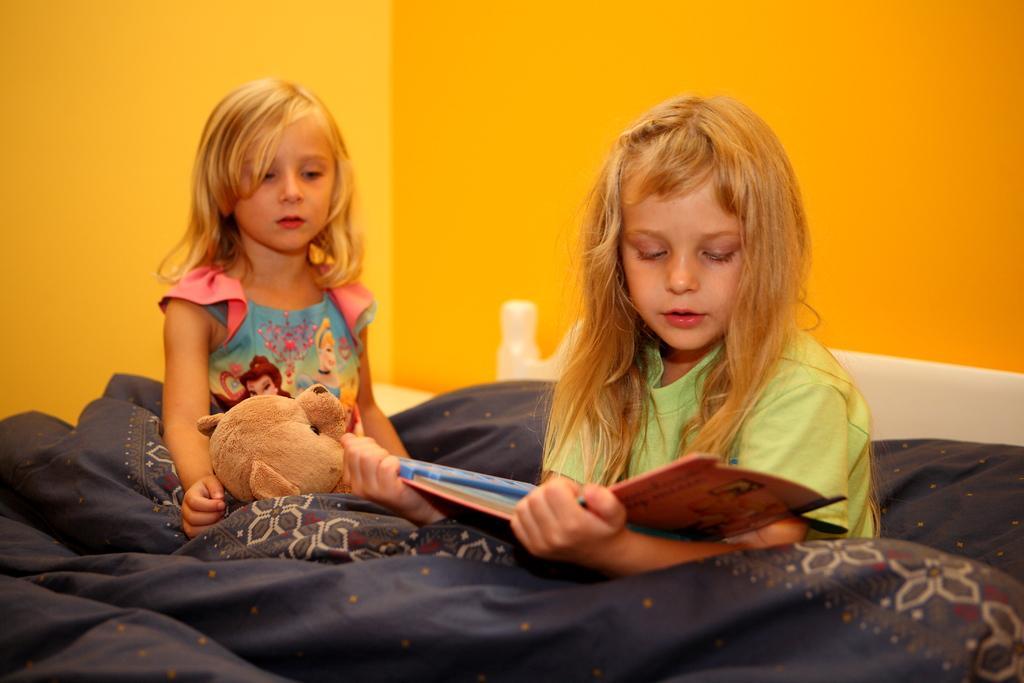Describe this image in one or two sentences. In this image there are two girls sitting on a bed. In the background of the image there is wall. 